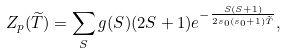<formula> <loc_0><loc_0><loc_500><loc_500>Z _ { p } ( \widetilde { T } ) = \sum _ { S } g ( S ) ( 2 S + 1 ) e ^ { - \frac { S ( S + 1 ) } { 2 s _ { 0 } ( s _ { 0 } + 1 ) \widetilde { T } } } ,</formula> 